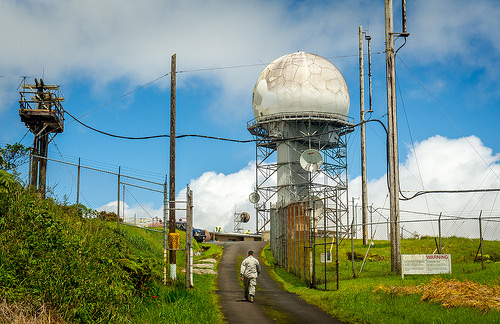<image>
Can you confirm if the satellite is to the right of the fence? No. The satellite is not to the right of the fence. The horizontal positioning shows a different relationship. 